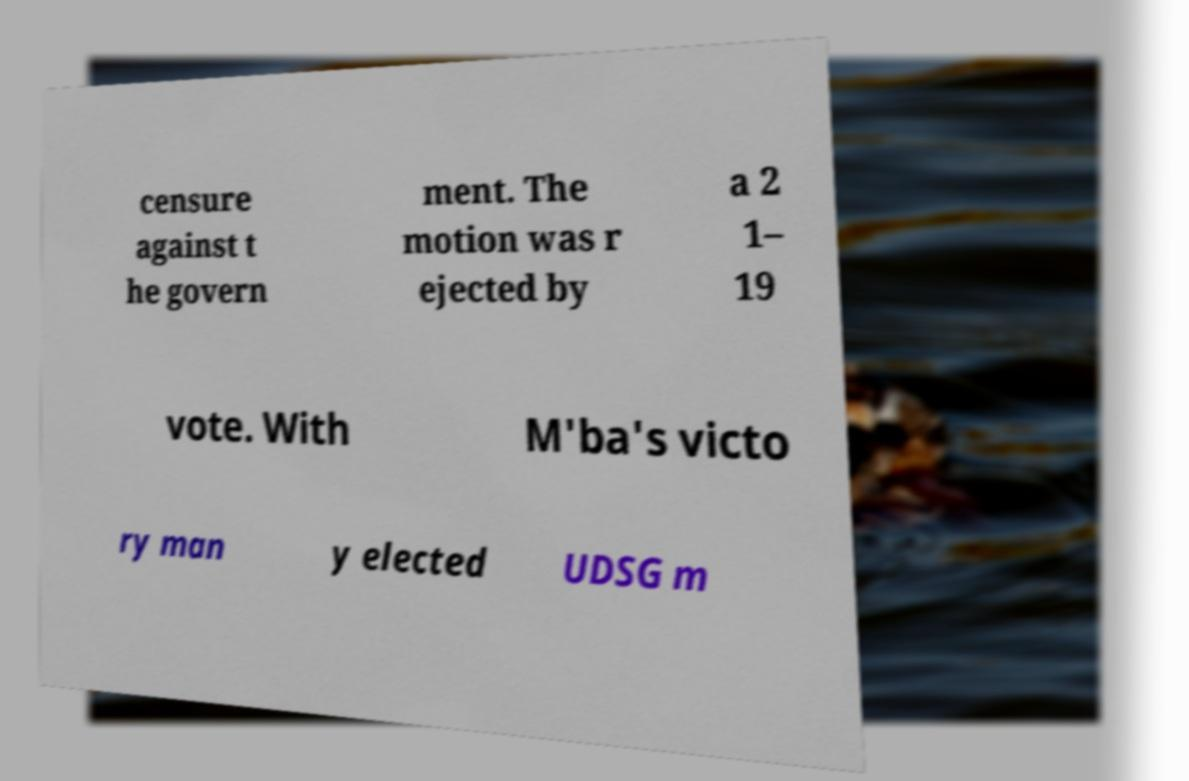There's text embedded in this image that I need extracted. Can you transcribe it verbatim? censure against t he govern ment. The motion was r ejected by a 2 1– 19 vote. With M'ba's victo ry man y elected UDSG m 